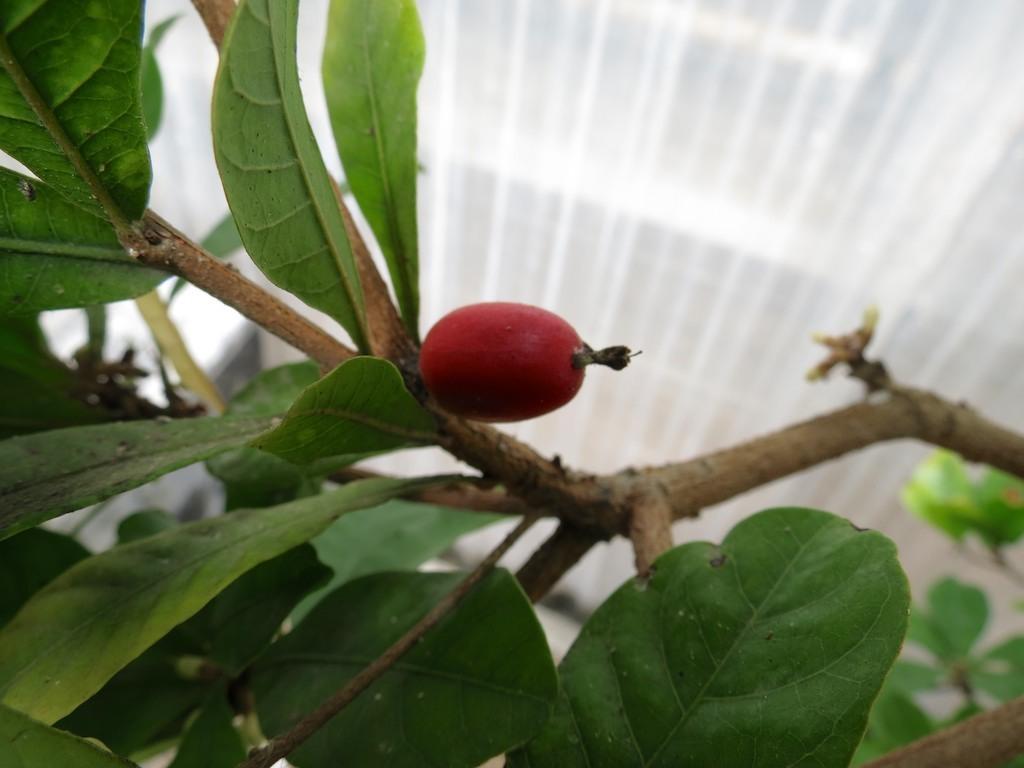Can you describe this image briefly? In the image we can see there is a fruit on the tree and on the top there is a roof. 